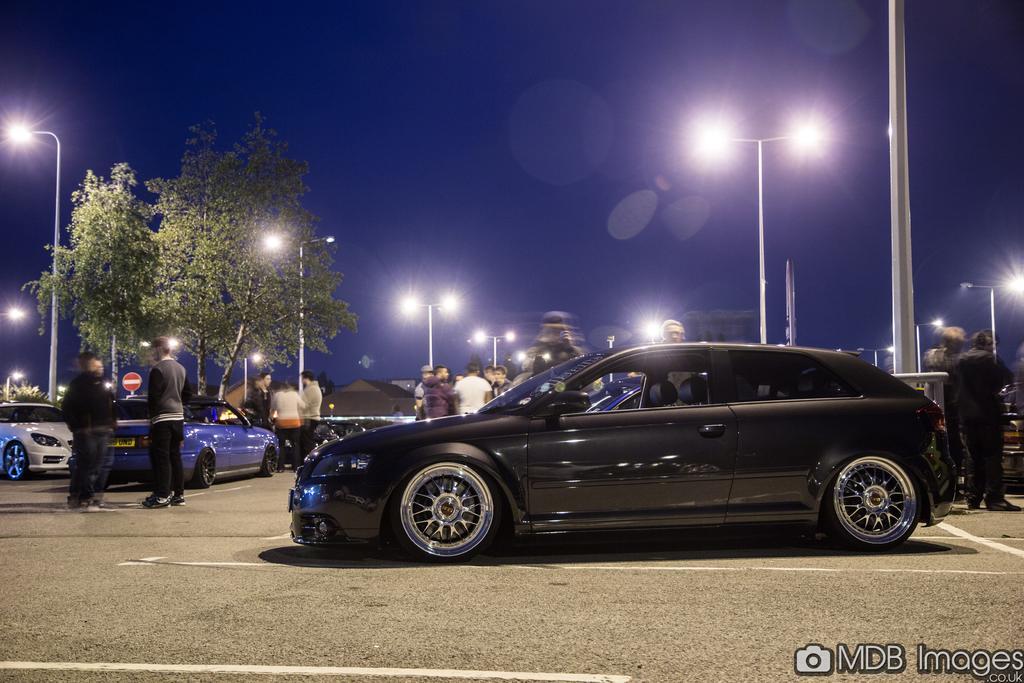How would you summarize this image in a sentence or two? In this picture we can see vehicles, people on the ground, here we can see electric poles with lights, houses, trees, some objects and we can see sky in the background, in the bottom right we can see some text on it. 